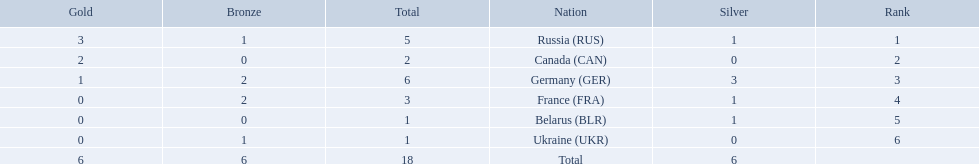Which countries competed in the 1995 biathlon? Russia (RUS), Canada (CAN), Germany (GER), France (FRA), Belarus (BLR), Ukraine (UKR). How many medals in total did they win? 5, 2, 6, 3, 1, 1. And which country had the most? Germany (GER). Which countries had one or more gold medals? Russia (RUS), Canada (CAN), Germany (GER). Of these countries, which had at least one silver medal? Russia (RUS), Germany (GER). Of the remaining countries, who had more medals overall? Germany (GER). 